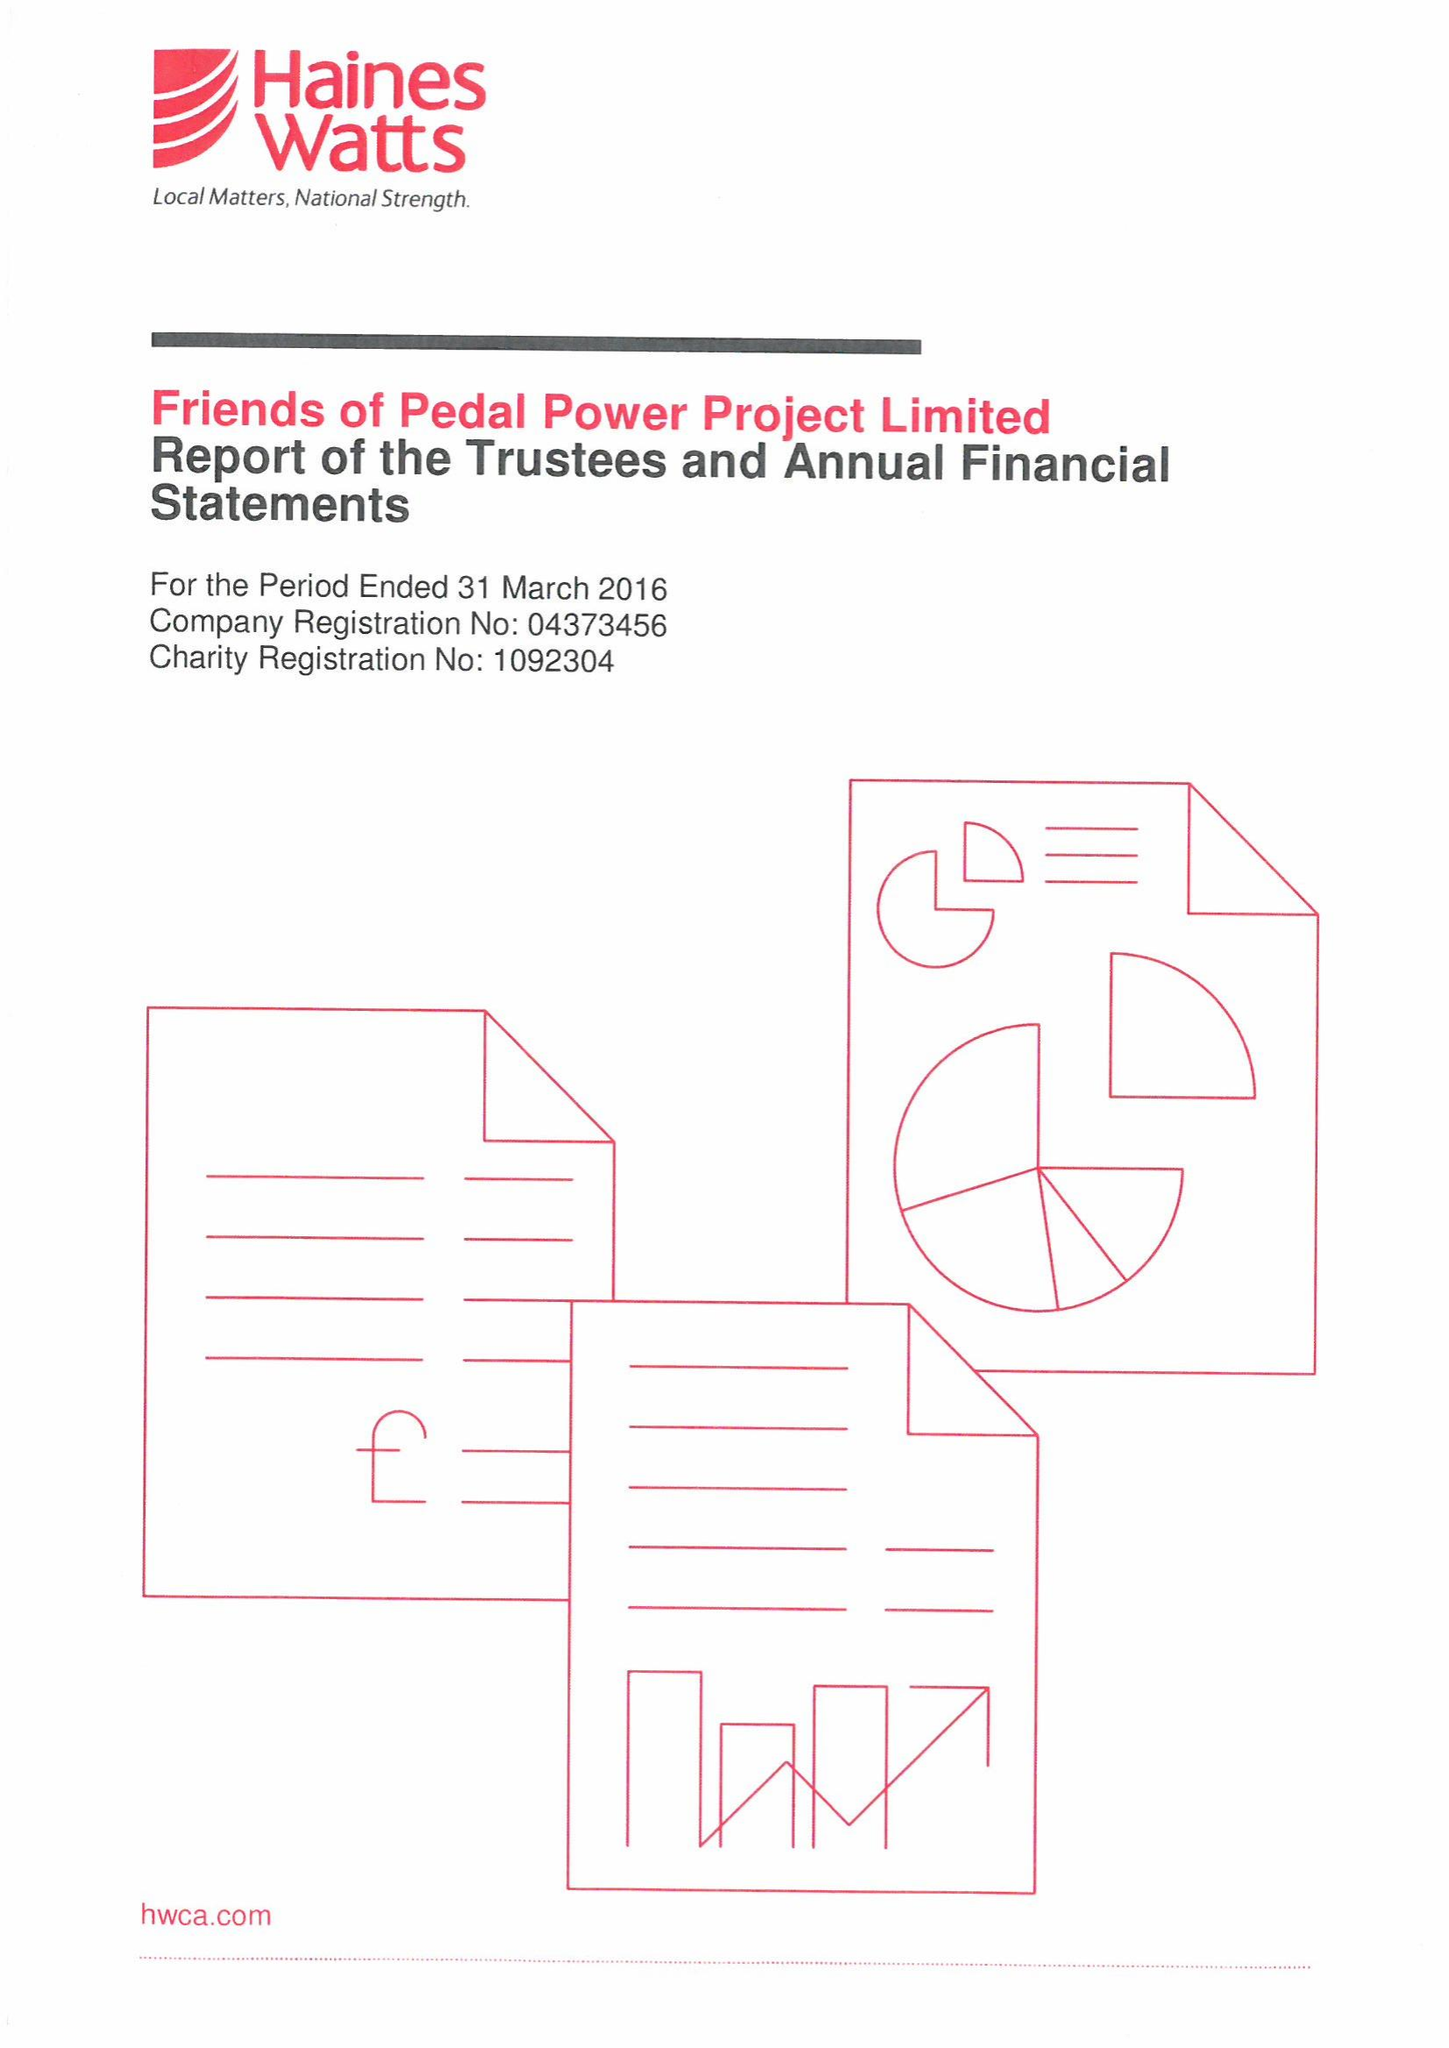What is the value for the report_date?
Answer the question using a single word or phrase. 2016-03-31 